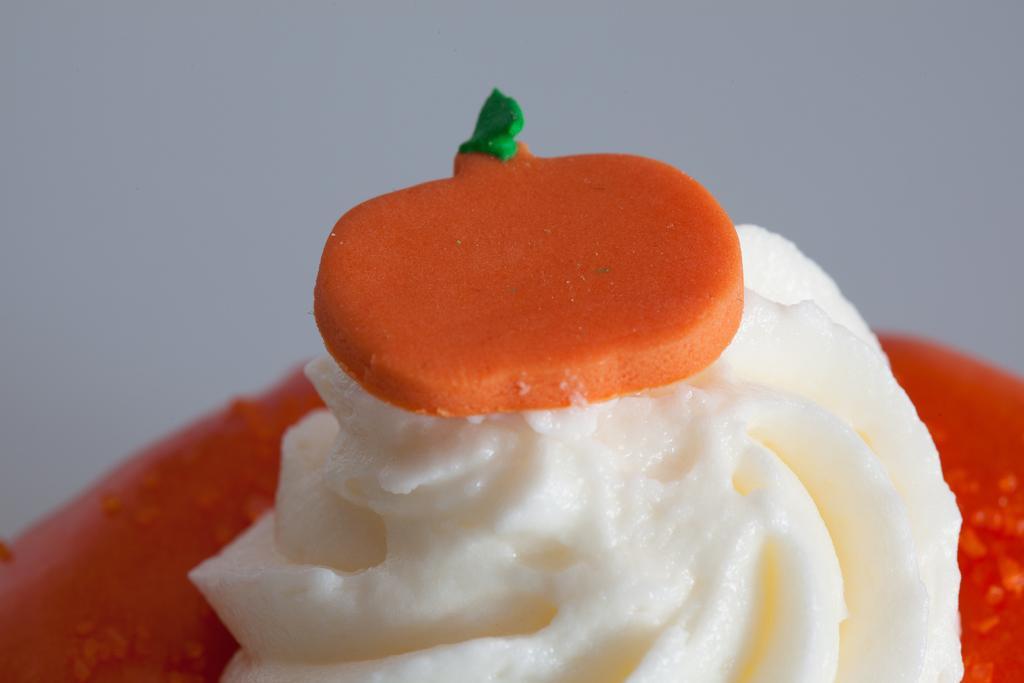Could you give a brief overview of what you see in this image? In this image, at the bottom there is a plate, on that there is an ice cream on that there is a topping. 